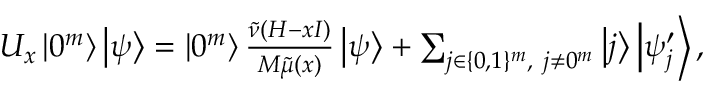<formula> <loc_0><loc_0><loc_500><loc_500>\begin{array} { r } { U _ { x } \left | 0 ^ { m } \right \rangle \left | \psi \right \rangle = \left | 0 ^ { m } \right \rangle \frac { \tilde { \nu } ( H - x I ) } { M \tilde { \mu } ( x ) } \left | \psi \right \rangle + \sum _ { j \in \{ 0 , 1 \} ^ { m } , j \neq 0 ^ { m } } \left | j \right \rangle \left | \psi _ { j } ^ { \prime } \right \rangle , } \end{array}</formula> 